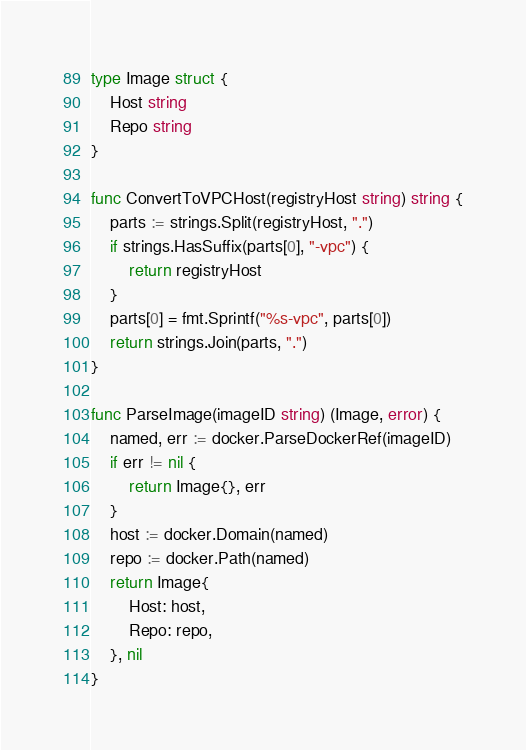<code> <loc_0><loc_0><loc_500><loc_500><_Go_>type Image struct {
	Host string
	Repo string
}

func ConvertToVPCHost(registryHost string) string {
	parts := strings.Split(registryHost, ".")
	if strings.HasSuffix(parts[0], "-vpc") {
		return registryHost
	}
	parts[0] = fmt.Sprintf("%s-vpc", parts[0])
	return strings.Join(parts, ".")
}

func ParseImage(imageID string) (Image, error) {
	named, err := docker.ParseDockerRef(imageID)
	if err != nil {
		return Image{}, err
	}
	host := docker.Domain(named)
	repo := docker.Path(named)
	return Image{
		Host: host,
		Repo: repo,
	}, nil
}
</code> 